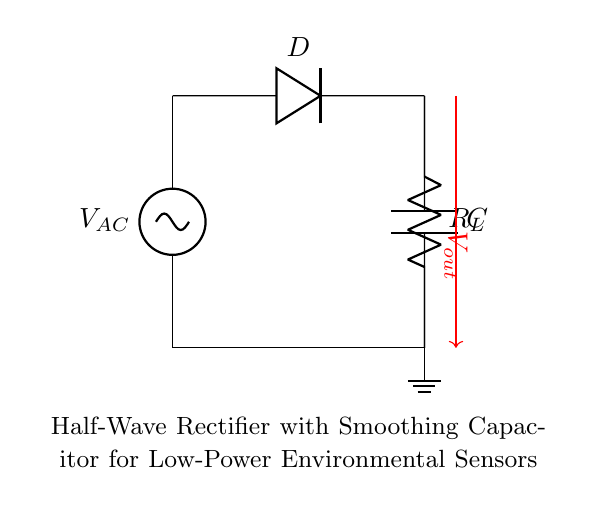What components are present in this circuit? The circuit consists of an AC source, a diode, a load resistor, and a smoothing capacitor. Each component is visually identifiable: the AC source is marked as V_AC, the diode is labeled D, the load resistor is identified as R_L, and the smoothing capacitor is marked as C.
Answer: AC source, diode, load resistor, smoothing capacitor What is the voltage across the load resistor? The output voltage V_out is taken across the load resistor, therefore the voltage across it is V_out in a half-wave rectifier configuration. This can be observed from the output arrow pointing out from the load resistor.
Answer: V_out How does the diode function in this circuit? The diode allows current to flow in one direction, thus converting the AC voltage into DC voltage during the positive half-cycle. When the AC voltage is negative, the diode blocks current flow, effectively “clipping” the negative portion of the waveform, which is fundamental to the operation of a half-wave rectifier.
Answer: Converts AC to DC What is the purpose of the smoothing capacitor? The smoothing capacitor is used to reduce voltage ripple in the output, providing a more stable DC voltage. It charges up when the output voltage rises and discharges when the voltage falls, smoothing out the variations inherent in the half-wave rectified output. This is critical for the steady operation of low-power environmental sensors.
Answer: Reduces voltage ripple In which direction does the current flow through the circuit during the positive half-cycle? During the positive half-cycle, the current flows from the AC source through the diode, then through the load resistor, and finally into the smoothing capacitor before returning to ground. This unidirectional flow is facilitated by the diode conducting only during the positive voltage phase.
Answer: From AC source to ground What type of rectifier is illustrated in this circuit? This circuit is designed as a half-wave rectifier, characterized by its use of a single diode to allow current only during one half of the AC cycle. This can be confirmed by the presence of only one diode connected in series with the load.
Answer: Half-wave rectifier 